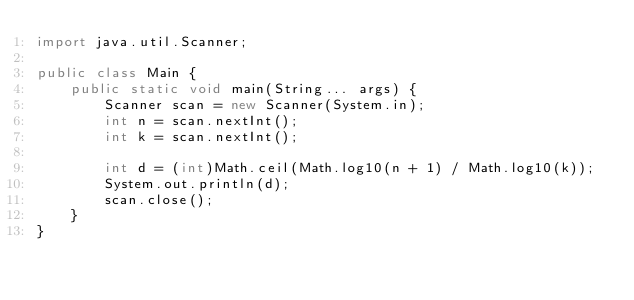<code> <loc_0><loc_0><loc_500><loc_500><_Java_>import java.util.Scanner;

public class Main {
	public static void main(String... args) {
		Scanner scan = new Scanner(System.in);
		int n = scan.nextInt();
		int k = scan.nextInt();

		int d = (int)Math.ceil(Math.log10(n + 1) / Math.log10(k));
		System.out.println(d);
		scan.close();
	}
}</code> 